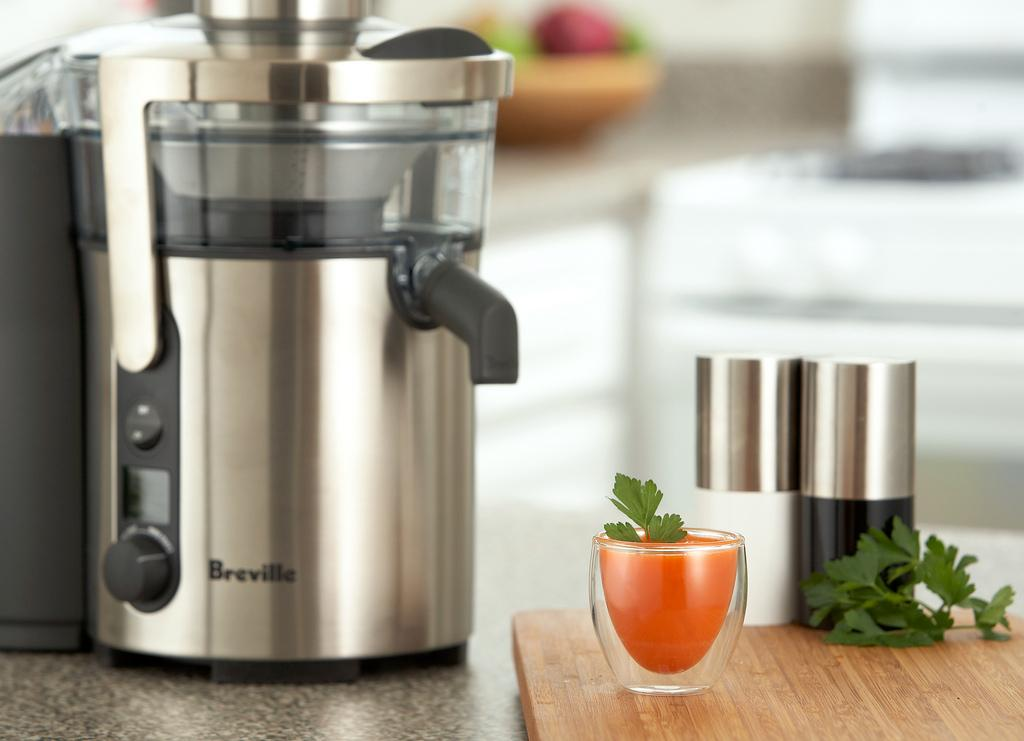<image>
Summarize the visual content of the image. A Breville juicer with juice next to the product 